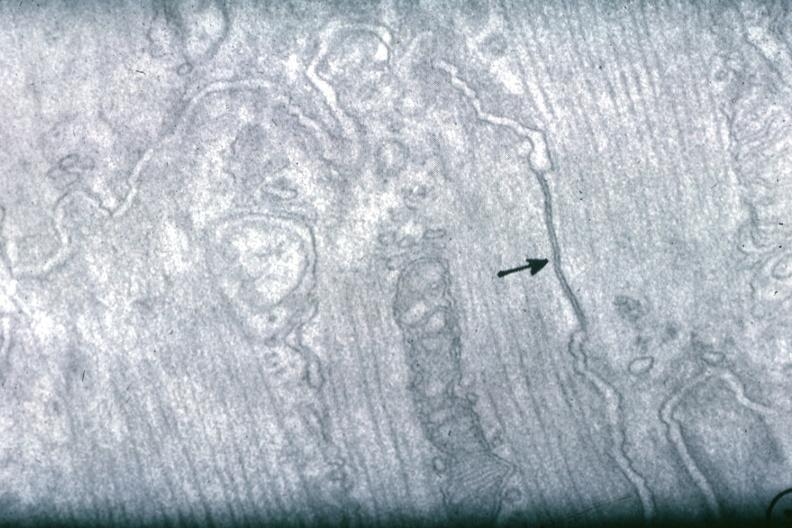does chest and abdomen slide show junctional complex between two cells?
Answer the question using a single word or phrase. No 